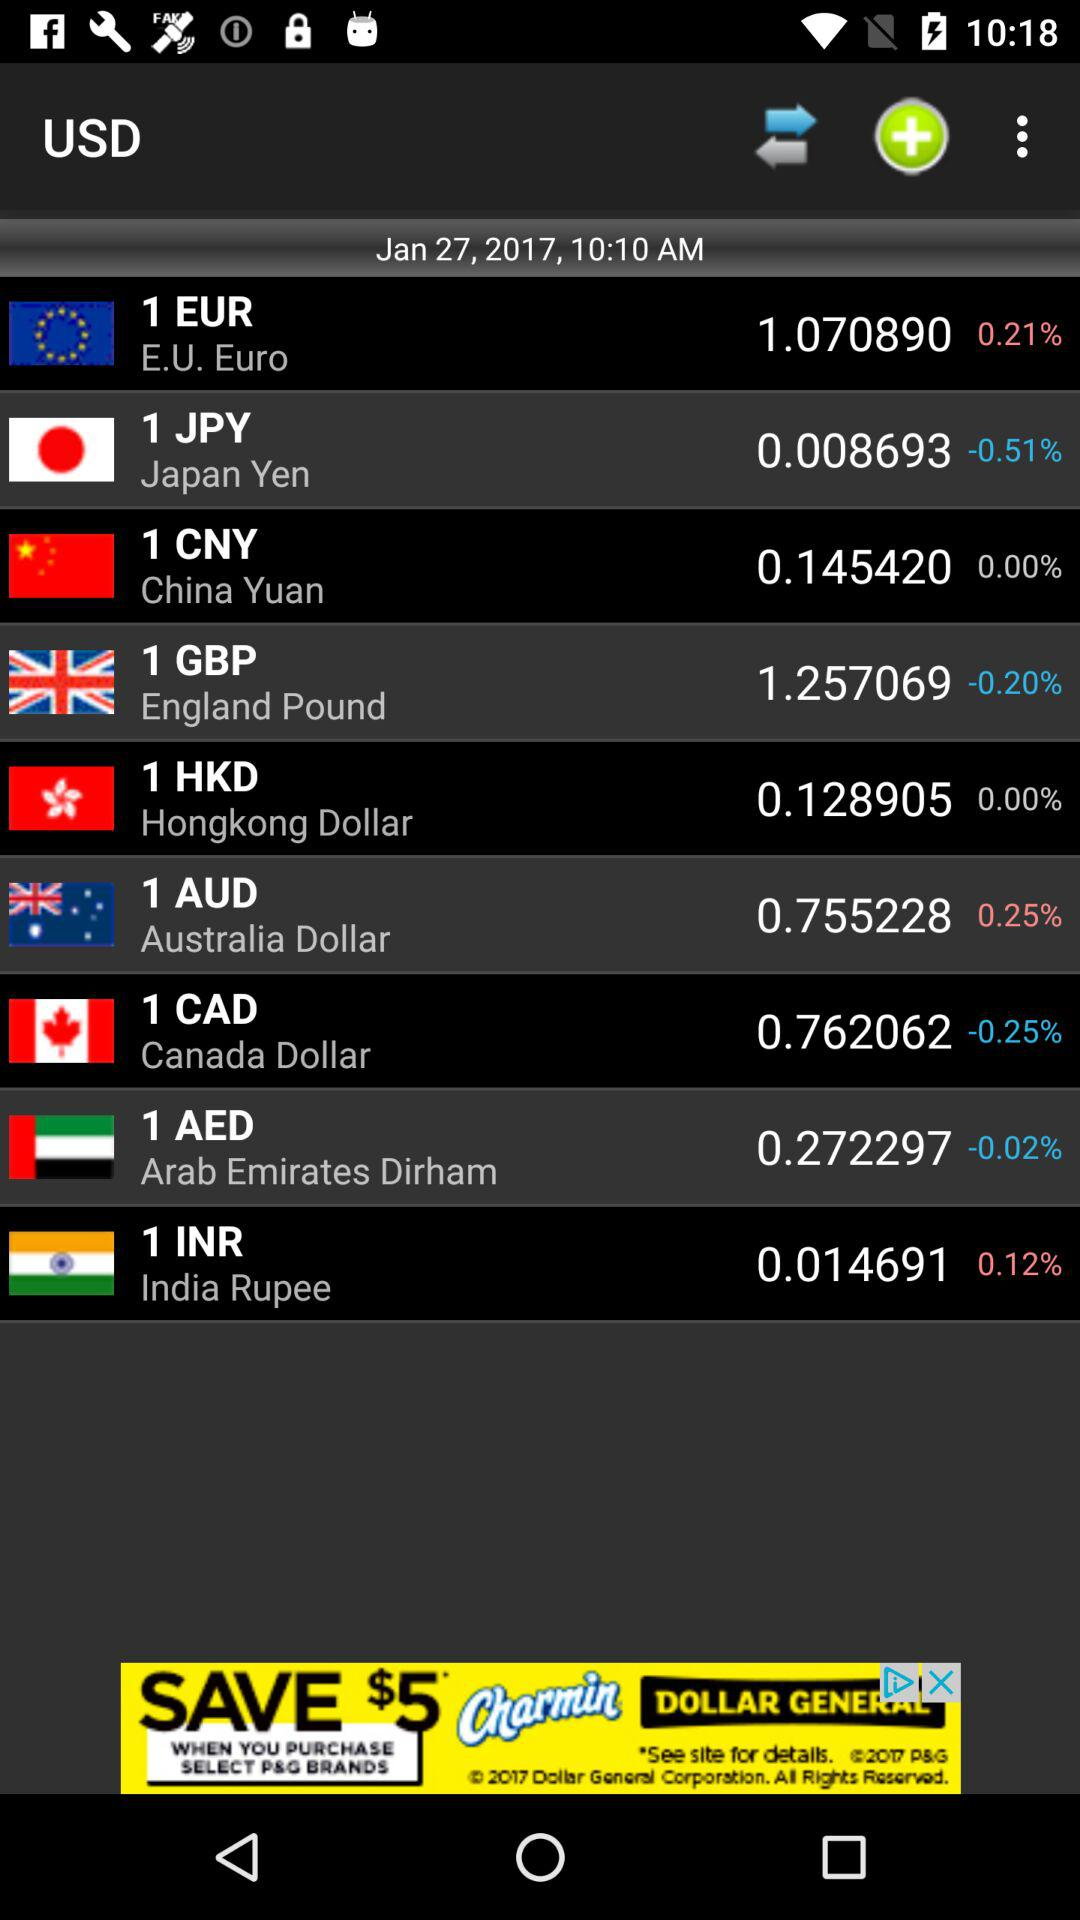What is the date? The date is January 27, 2017. 